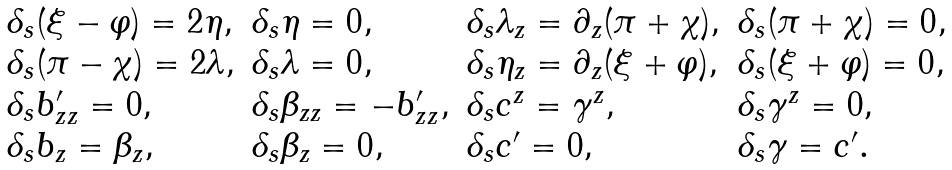Convert formula to latex. <formula><loc_0><loc_0><loc_500><loc_500>\begin{array} { l l l l } { { \delta _ { s } ( \xi - \varphi ) = 2 \eta , } } & { { \delta _ { s } \eta = 0 , } } & { { \delta _ { s } \lambda _ { z } = \partial _ { z } ( \pi + \chi ) , } } & { { \delta _ { s } ( \pi + \chi ) = 0 , } } \\ { { \delta _ { s } ( \pi - \chi ) = 2 \lambda , } } & { { \delta _ { s } \lambda = 0 , } } & { { \delta _ { s } \eta _ { z } = \partial _ { z } ( \xi + \varphi ) , } } & { { \delta _ { s } ( \xi + \varphi ) = 0 , } } \\ { { \delta _ { s } b _ { z z } ^ { \prime } = 0 , } } & { { \delta _ { s } \beta _ { z z } = - b _ { z z } ^ { \prime } , } } & { { \delta _ { s } c ^ { z } = \gamma ^ { z } , } } & { { \delta _ { s } \gamma ^ { z } = 0 , } } \\ { { \delta _ { s } b _ { z } = \beta _ { z } , } } & { { \delta _ { s } \beta _ { z } = 0 , } } & { { \delta _ { s } c ^ { \prime } = 0 , } } & { { \delta _ { s } \gamma = c ^ { \prime } . } } \end{array}</formula> 